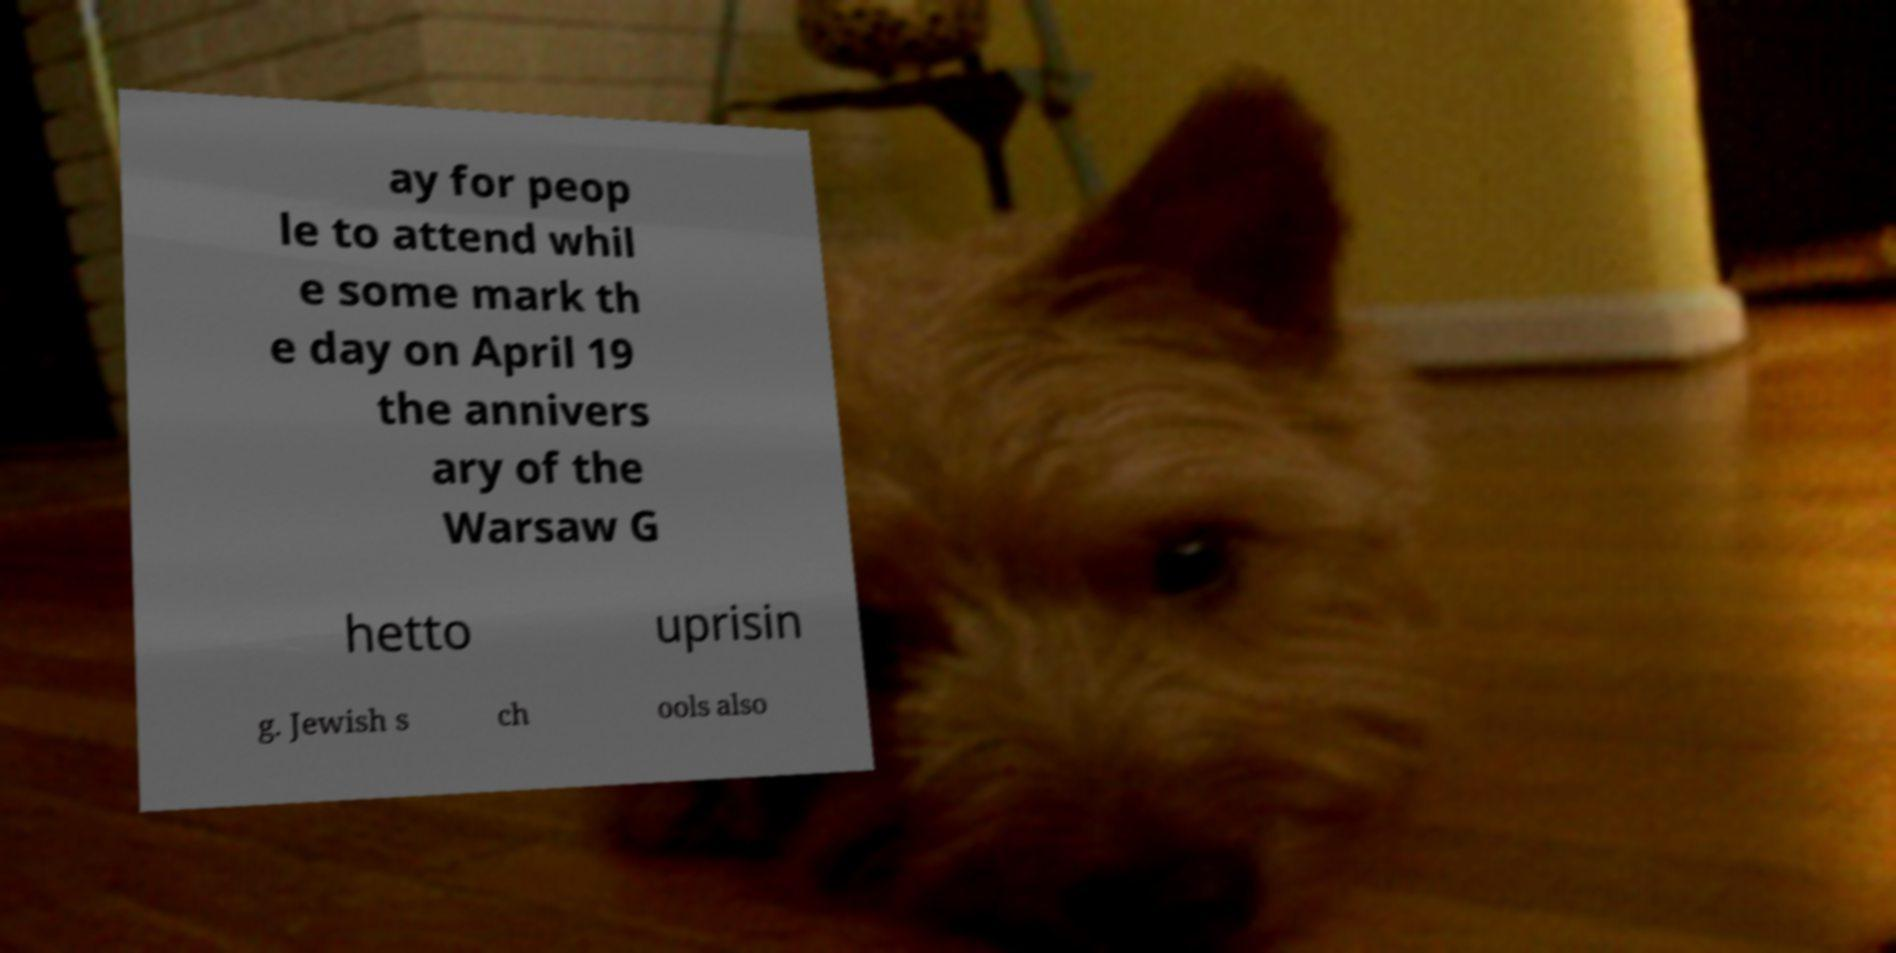There's text embedded in this image that I need extracted. Can you transcribe it verbatim? ay for peop le to attend whil e some mark th e day on April 19 the annivers ary of the Warsaw G hetto uprisin g. Jewish s ch ools also 